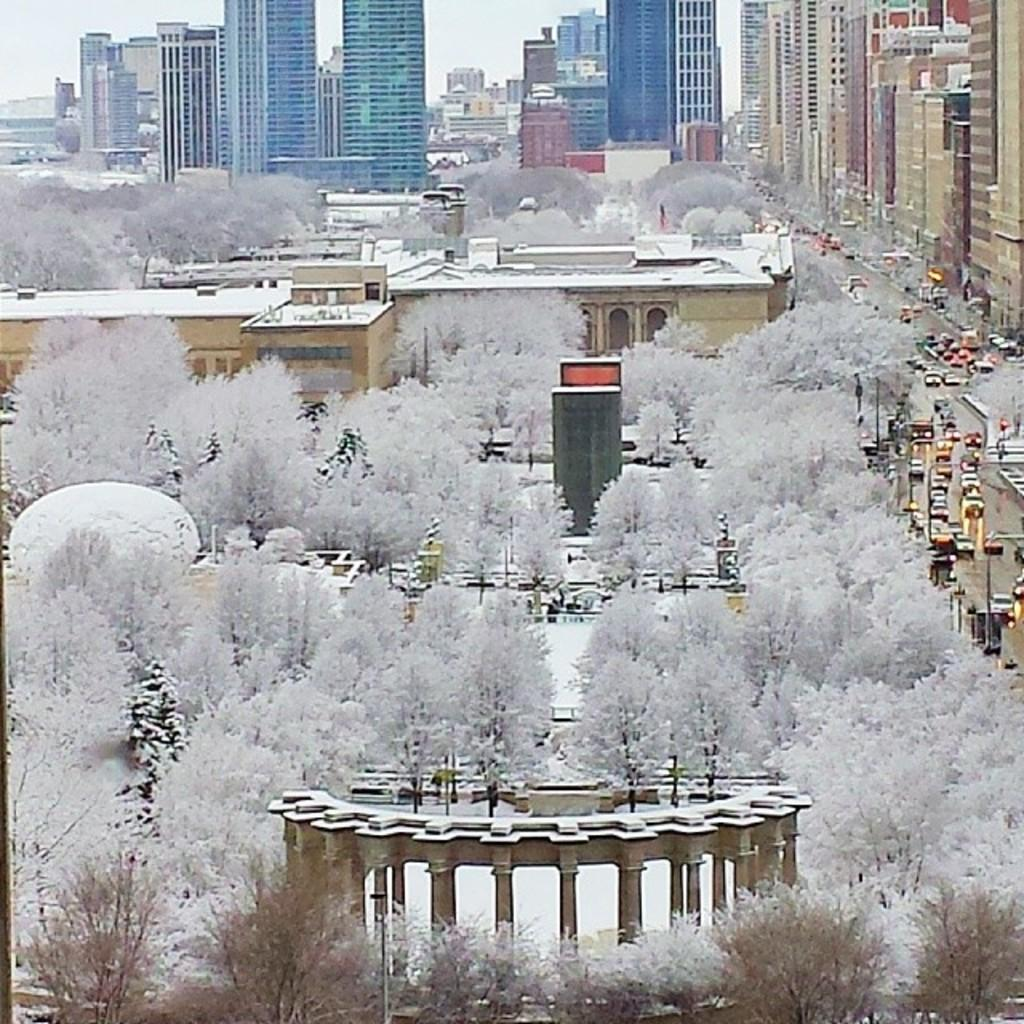What is present on the road in the image? There are vehicles on the road in the image. What type of natural elements can be seen in the image? Trees are visible in the image. What structures are present in the image? Poles and buildings are present in the image. What is visible in the background of the image? The sky is visible in the background of the image. What type of flag is waving in the image? There is no flag present in the image. What kind of ball is being used by the people in the image? There are no people or balls present in the image. 